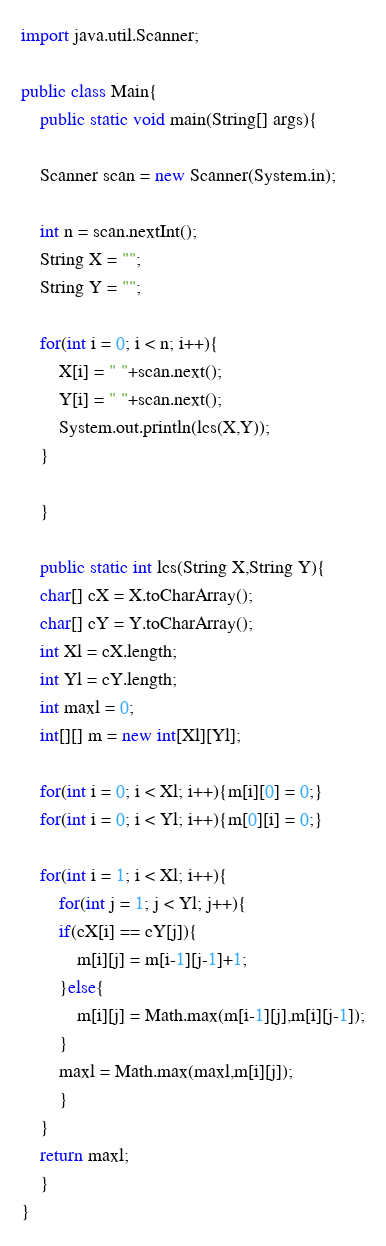Convert code to text. <code><loc_0><loc_0><loc_500><loc_500><_Java_>import java.util.Scanner;

public class Main{
    public static void main(String[] args){
	
	Scanner scan = new Scanner(System.in);
	
	int n = scan.nextInt();
	String X = "";
	String Y = "";
	
	for(int i = 0; i < n; i++){
	    X[i] = " "+scan.next();
	    Y[i] = " "+scan.next();
	    System.out.println(lcs(X,Y));
	}
	
    }

    public static int lcs(String X,String Y){
	char[] cX = X.toCharArray();
	char[] cY = Y.toCharArray();
	int Xl = cX.length;
	int Yl = cY.length;
	int maxl = 0;
	int[][] m = new int[Xl][Yl];

	for(int i = 0; i < Xl; i++){m[i][0] = 0;}
	for(int i = 0; i < Yl; i++){m[0][i] = 0;}

	for(int i = 1; i < Xl; i++){
	    for(int j = 1; j < Yl; j++){
		if(cX[i] == cY[j]){
		    m[i][j] = m[i-1][j-1]+1;
		}else{
		    m[i][j] = Math.max(m[i-1][j],m[i][j-1]);
		}
		maxl = Math.max(maxl,m[i][j]);
	    }
	}
	return maxl;
    }
}</code> 